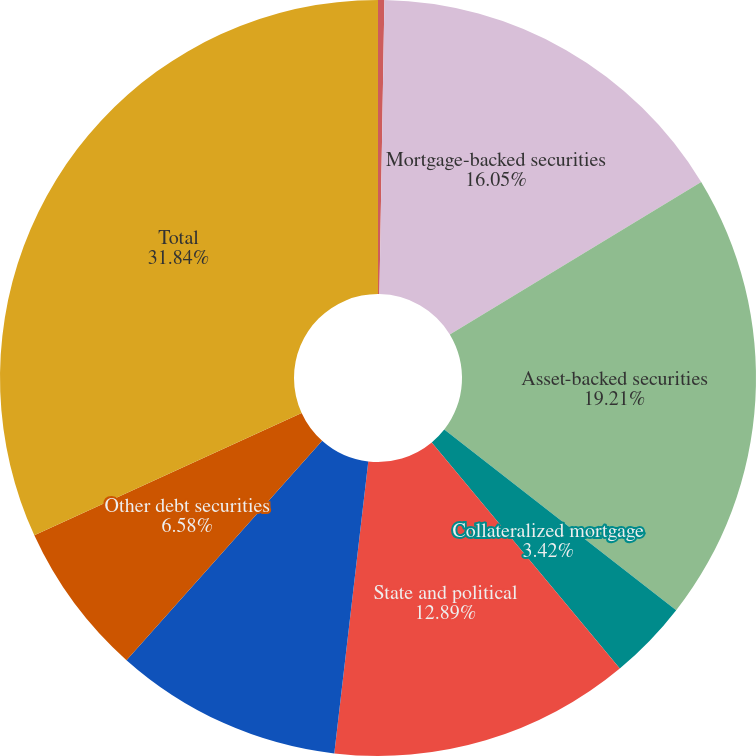Convert chart to OTSL. <chart><loc_0><loc_0><loc_500><loc_500><pie_chart><fcel>Direct obligations<fcel>Mortgage-backed securities<fcel>Asset-backed securities<fcel>Collateralized mortgage<fcel>State and political<fcel>Non-US debt securities<fcel>Other debt securities<fcel>Total<nl><fcel>0.27%<fcel>16.05%<fcel>19.21%<fcel>3.42%<fcel>12.89%<fcel>9.74%<fcel>6.58%<fcel>31.83%<nl></chart> 